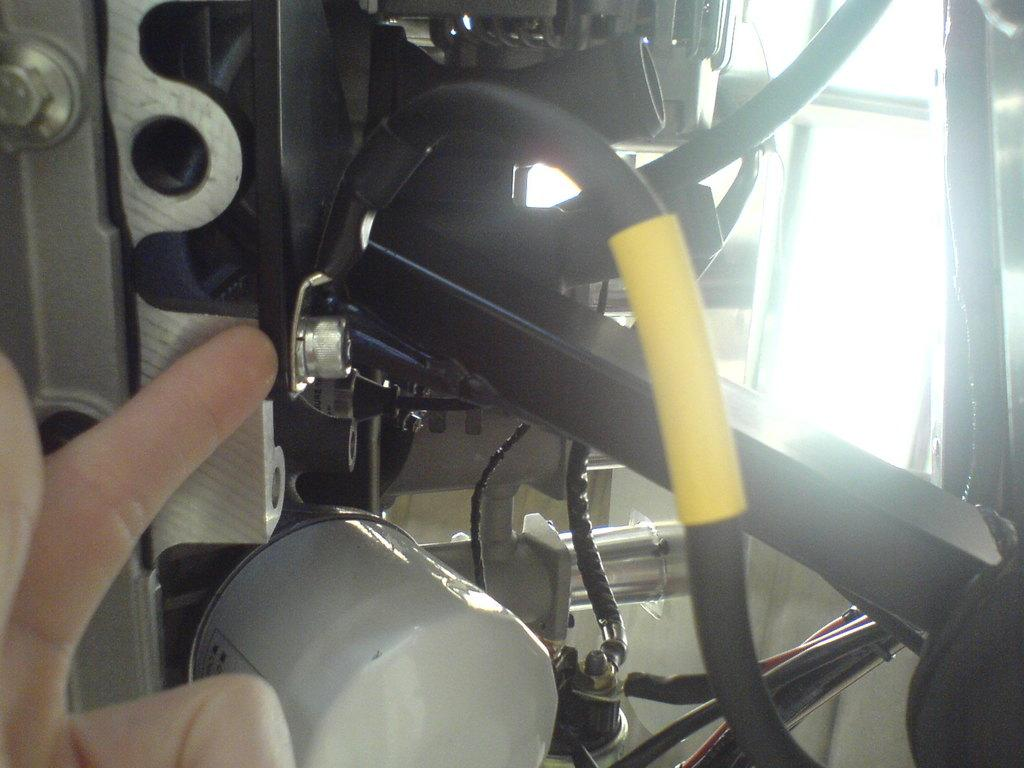What is the main object in the image? There is a machine in the image. Can you describe any human interaction with the machine? A human hand is visible in the image. What type of grass can be seen growing near the machine in the image? There is no grass visible in the image; it is focused on the machine and a human hand. 